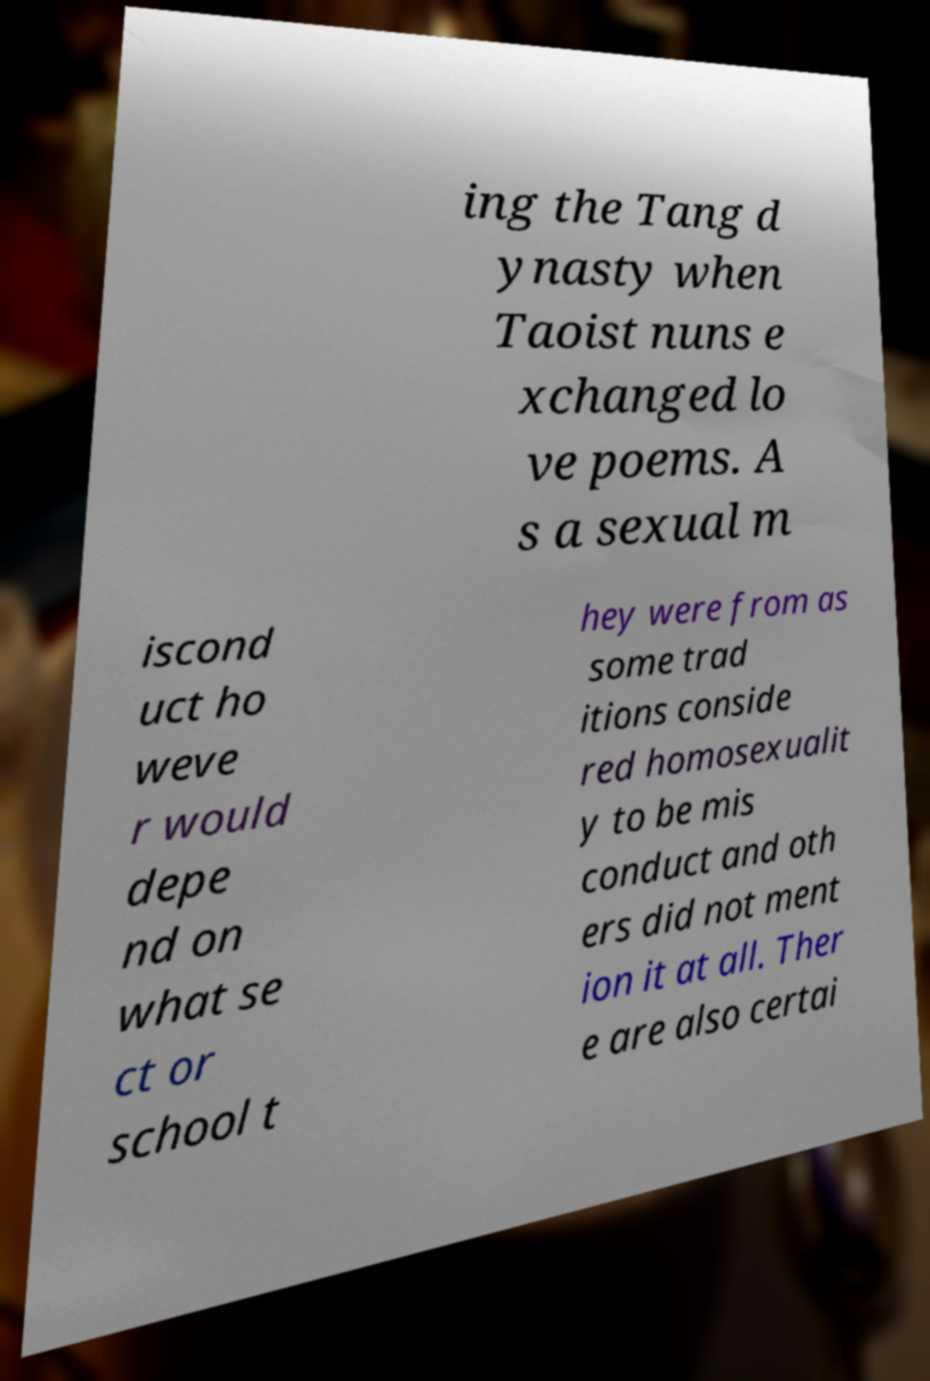I need the written content from this picture converted into text. Can you do that? ing the Tang d ynasty when Taoist nuns e xchanged lo ve poems. A s a sexual m iscond uct ho weve r would depe nd on what se ct or school t hey were from as some trad itions conside red homosexualit y to be mis conduct and oth ers did not ment ion it at all. Ther e are also certai 